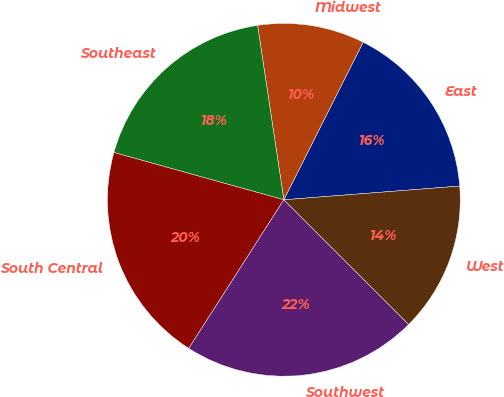Convert chart. <chart><loc_0><loc_0><loc_500><loc_500><pie_chart><fcel>East<fcel>Midwest<fcel>Southeast<fcel>South Central<fcel>Southwest<fcel>West<nl><fcel>16.34%<fcel>9.8%<fcel>18.3%<fcel>20.26%<fcel>21.57%<fcel>13.73%<nl></chart> 